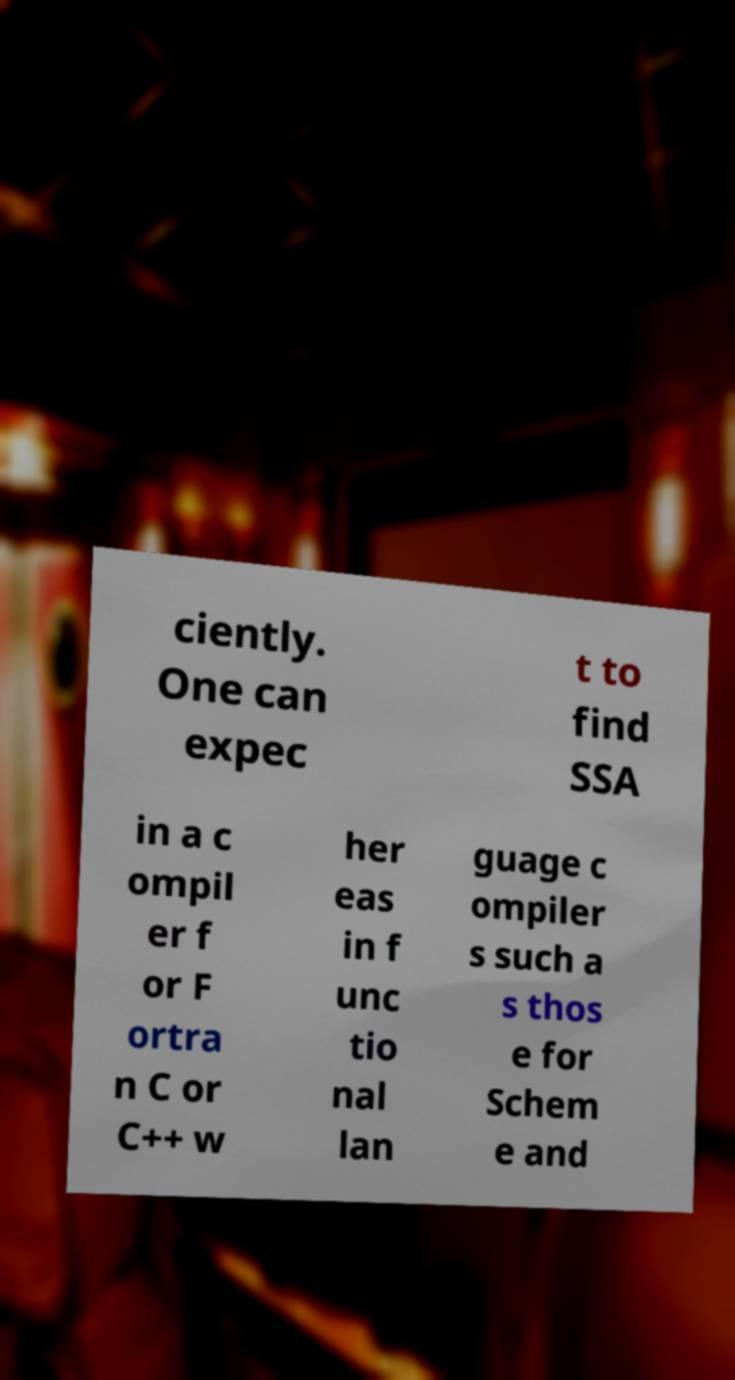Please read and relay the text visible in this image. What does it say? ciently. One can expec t to find SSA in a c ompil er f or F ortra n C or C++ w her eas in f unc tio nal lan guage c ompiler s such a s thos e for Schem e and 